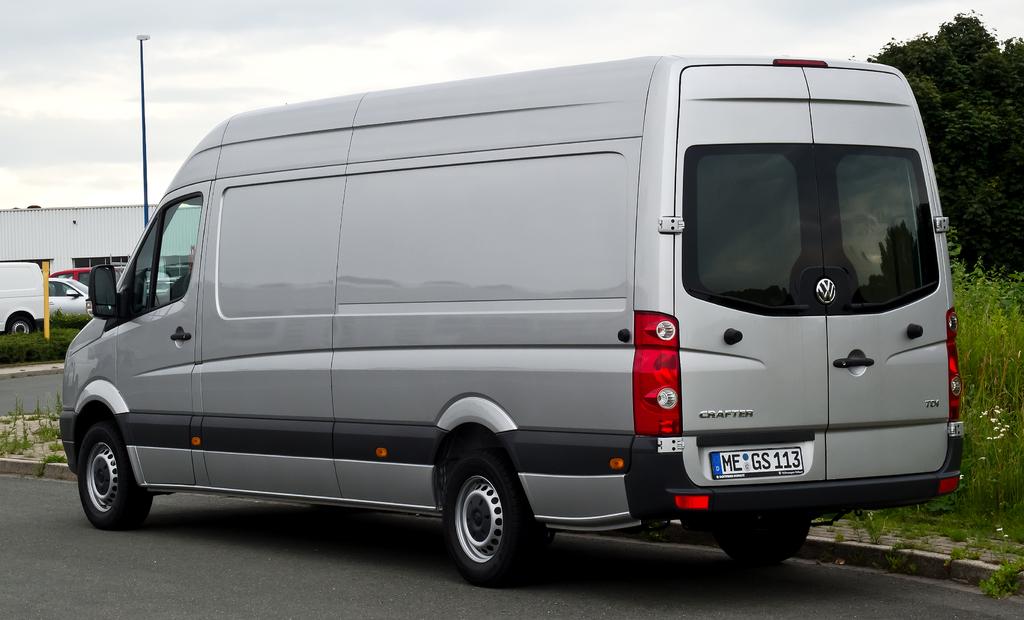What is the model of van?
Provide a succinct answer. Crafter. What numbers are written on the license tag of the grey van?
Give a very brief answer. 113. 